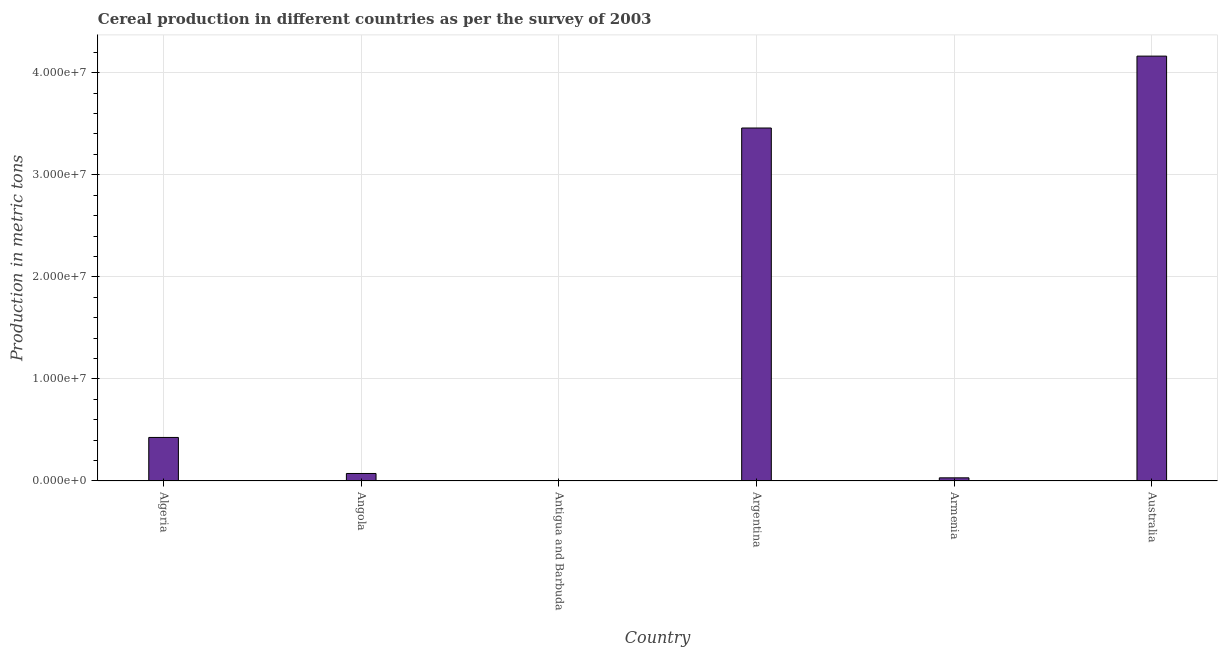Does the graph contain grids?
Ensure brevity in your answer.  Yes. What is the title of the graph?
Your answer should be very brief. Cereal production in different countries as per the survey of 2003. What is the label or title of the X-axis?
Give a very brief answer. Country. What is the label or title of the Y-axis?
Your response must be concise. Production in metric tons. What is the cereal production in Argentina?
Your answer should be compact. 3.46e+07. Across all countries, what is the maximum cereal production?
Offer a very short reply. 4.16e+07. In which country was the cereal production maximum?
Your response must be concise. Australia. In which country was the cereal production minimum?
Keep it short and to the point. Antigua and Barbuda. What is the sum of the cereal production?
Provide a succinct answer. 8.15e+07. What is the difference between the cereal production in Armenia and Australia?
Offer a terse response. -4.13e+07. What is the average cereal production per country?
Provide a succinct answer. 1.36e+07. What is the median cereal production?
Your answer should be compact. 2.50e+06. What is the ratio of the cereal production in Angola to that in Argentina?
Provide a short and direct response. 0.02. What is the difference between the highest and the second highest cereal production?
Provide a succinct answer. 7.04e+06. Is the sum of the cereal production in Algeria and Antigua and Barbuda greater than the maximum cereal production across all countries?
Your response must be concise. No. What is the difference between the highest and the lowest cereal production?
Ensure brevity in your answer.  4.16e+07. In how many countries, is the cereal production greater than the average cereal production taken over all countries?
Your answer should be compact. 2. What is the difference between two consecutive major ticks on the Y-axis?
Your answer should be very brief. 1.00e+07. Are the values on the major ticks of Y-axis written in scientific E-notation?
Provide a succinct answer. Yes. What is the Production in metric tons of Algeria?
Offer a very short reply. 4.27e+06. What is the Production in metric tons of Angola?
Offer a very short reply. 7.37e+05. What is the Production in metric tons in Antigua and Barbuda?
Your answer should be very brief. 55. What is the Production in metric tons of Argentina?
Give a very brief answer. 3.46e+07. What is the Production in metric tons of Armenia?
Give a very brief answer. 3.10e+05. What is the Production in metric tons of Australia?
Offer a very short reply. 4.16e+07. What is the difference between the Production in metric tons in Algeria and Angola?
Offer a very short reply. 3.53e+06. What is the difference between the Production in metric tons in Algeria and Antigua and Barbuda?
Offer a very short reply. 4.27e+06. What is the difference between the Production in metric tons in Algeria and Argentina?
Offer a terse response. -3.03e+07. What is the difference between the Production in metric tons in Algeria and Armenia?
Offer a terse response. 3.96e+06. What is the difference between the Production in metric tons in Algeria and Australia?
Your response must be concise. -3.74e+07. What is the difference between the Production in metric tons in Angola and Antigua and Barbuda?
Your answer should be very brief. 7.37e+05. What is the difference between the Production in metric tons in Angola and Argentina?
Offer a very short reply. -3.38e+07. What is the difference between the Production in metric tons in Angola and Armenia?
Ensure brevity in your answer.  4.27e+05. What is the difference between the Production in metric tons in Angola and Australia?
Provide a succinct answer. -4.09e+07. What is the difference between the Production in metric tons in Antigua and Barbuda and Argentina?
Provide a succinct answer. -3.46e+07. What is the difference between the Production in metric tons in Antigua and Barbuda and Armenia?
Make the answer very short. -3.10e+05. What is the difference between the Production in metric tons in Antigua and Barbuda and Australia?
Make the answer very short. -4.16e+07. What is the difference between the Production in metric tons in Argentina and Armenia?
Keep it short and to the point. 3.43e+07. What is the difference between the Production in metric tons in Argentina and Australia?
Keep it short and to the point. -7.04e+06. What is the difference between the Production in metric tons in Armenia and Australia?
Your answer should be very brief. -4.13e+07. What is the ratio of the Production in metric tons in Algeria to that in Angola?
Make the answer very short. 5.79. What is the ratio of the Production in metric tons in Algeria to that in Antigua and Barbuda?
Keep it short and to the point. 7.76e+04. What is the ratio of the Production in metric tons in Algeria to that in Argentina?
Make the answer very short. 0.12. What is the ratio of the Production in metric tons in Algeria to that in Armenia?
Offer a very short reply. 13.78. What is the ratio of the Production in metric tons in Algeria to that in Australia?
Offer a very short reply. 0.1. What is the ratio of the Production in metric tons in Angola to that in Antigua and Barbuda?
Offer a very short reply. 1.34e+04. What is the ratio of the Production in metric tons in Angola to that in Argentina?
Your answer should be very brief. 0.02. What is the ratio of the Production in metric tons in Angola to that in Armenia?
Offer a very short reply. 2.38. What is the ratio of the Production in metric tons in Angola to that in Australia?
Your answer should be very brief. 0.02. What is the ratio of the Production in metric tons in Argentina to that in Armenia?
Provide a succinct answer. 111.72. What is the ratio of the Production in metric tons in Argentina to that in Australia?
Offer a very short reply. 0.83. What is the ratio of the Production in metric tons in Armenia to that in Australia?
Provide a short and direct response. 0.01. 